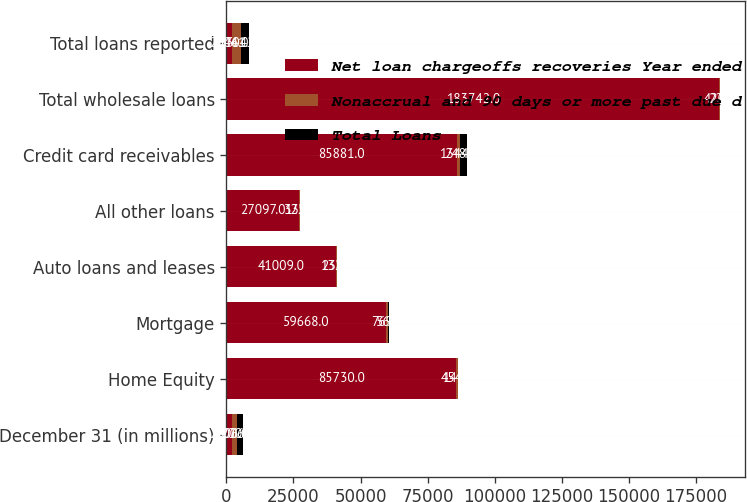<chart> <loc_0><loc_0><loc_500><loc_500><stacked_bar_chart><ecel><fcel>December 31 (in millions)<fcel>Home Equity<fcel>Mortgage<fcel>Auto loans and leases<fcel>All other loans<fcel>Credit card receivables<fcel>Total wholesale loans<fcel>Total loans reported<nl><fcel>Net loan chargeoffs recoveries Year ended<fcel>2006<fcel>85730<fcel>59668<fcel>41009<fcel>27097<fcel>85881<fcel>183742<fcel>2006<nl><fcel>Nonaccrual and 90 days or more past due d<fcel>2006<fcel>454<fcel>769<fcel>132<fcel>322<fcel>1344<fcel>420<fcel>3441<nl><fcel>Total Loans<fcel>2006<fcel>143<fcel>56<fcel>238<fcel>139<fcel>2488<fcel>22<fcel>3042<nl></chart> 